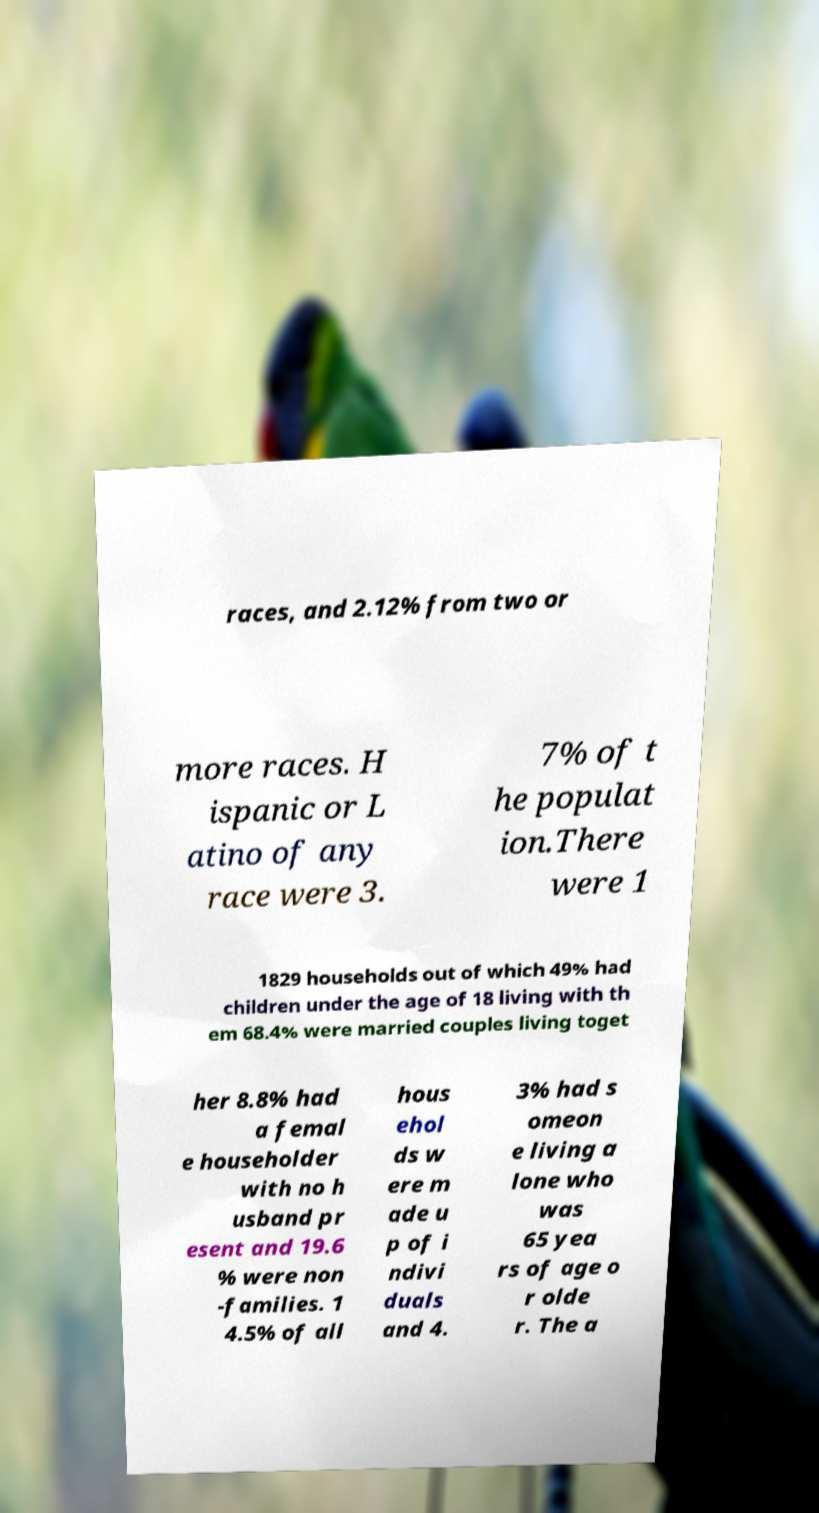Could you assist in decoding the text presented in this image and type it out clearly? races, and 2.12% from two or more races. H ispanic or L atino of any race were 3. 7% of t he populat ion.There were 1 1829 households out of which 49% had children under the age of 18 living with th em 68.4% were married couples living toget her 8.8% had a femal e householder with no h usband pr esent and 19.6 % were non -families. 1 4.5% of all hous ehol ds w ere m ade u p of i ndivi duals and 4. 3% had s omeon e living a lone who was 65 yea rs of age o r olde r. The a 